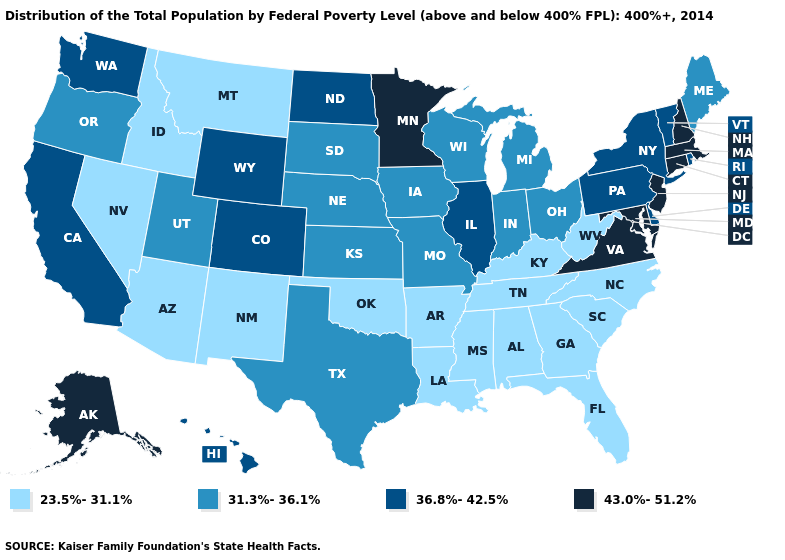What is the highest value in the USA?
Be succinct. 43.0%-51.2%. Does the map have missing data?
Give a very brief answer. No. Which states hav the highest value in the West?
Answer briefly. Alaska. Does Hawaii have the lowest value in the West?
Answer briefly. No. Name the states that have a value in the range 31.3%-36.1%?
Be succinct. Indiana, Iowa, Kansas, Maine, Michigan, Missouri, Nebraska, Ohio, Oregon, South Dakota, Texas, Utah, Wisconsin. Which states have the highest value in the USA?
Be succinct. Alaska, Connecticut, Maryland, Massachusetts, Minnesota, New Hampshire, New Jersey, Virginia. Does Alaska have the highest value in the West?
Answer briefly. Yes. How many symbols are there in the legend?
Keep it brief. 4. Name the states that have a value in the range 36.8%-42.5%?
Keep it brief. California, Colorado, Delaware, Hawaii, Illinois, New York, North Dakota, Pennsylvania, Rhode Island, Vermont, Washington, Wyoming. Among the states that border Connecticut , which have the highest value?
Give a very brief answer. Massachusetts. Among the states that border Delaware , does Pennsylvania have the lowest value?
Keep it brief. Yes. Name the states that have a value in the range 43.0%-51.2%?
Give a very brief answer. Alaska, Connecticut, Maryland, Massachusetts, Minnesota, New Hampshire, New Jersey, Virginia. Name the states that have a value in the range 43.0%-51.2%?
Write a very short answer. Alaska, Connecticut, Maryland, Massachusetts, Minnesota, New Hampshire, New Jersey, Virginia. Name the states that have a value in the range 36.8%-42.5%?
Keep it brief. California, Colorado, Delaware, Hawaii, Illinois, New York, North Dakota, Pennsylvania, Rhode Island, Vermont, Washington, Wyoming. What is the value of Florida?
Write a very short answer. 23.5%-31.1%. 